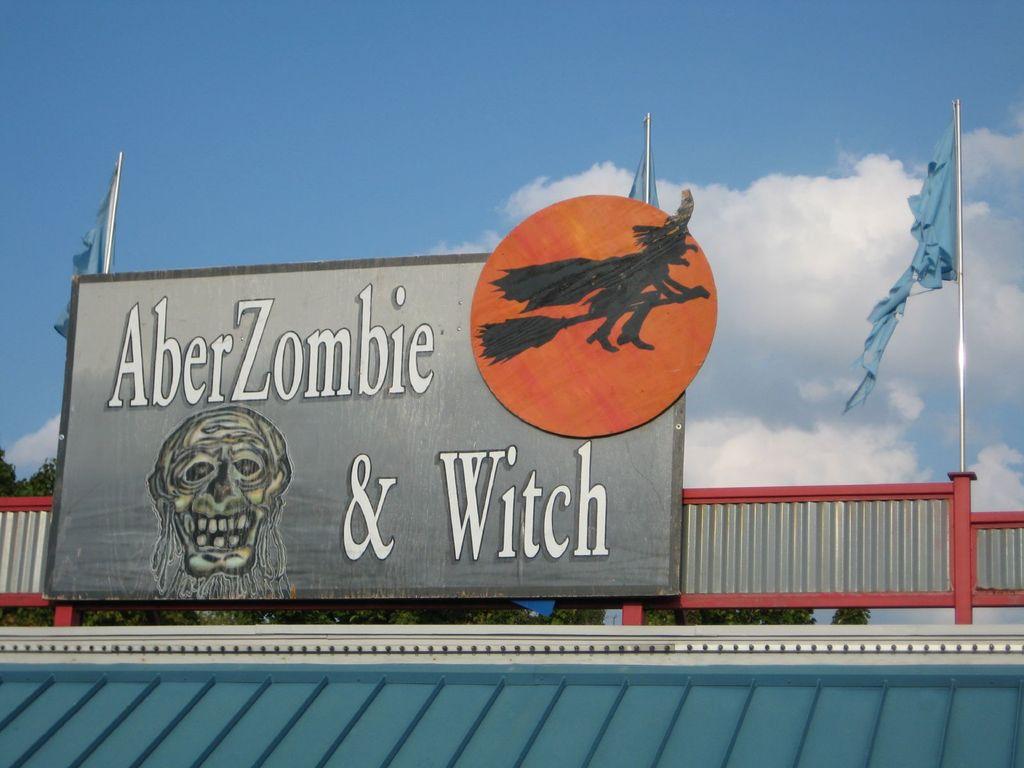What color are the big letters in ?
Offer a very short reply. White. What is the name?
Provide a short and direct response. Aberzombie & witch. 